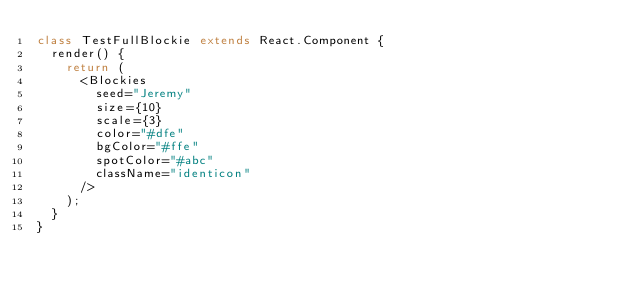<code> <loc_0><loc_0><loc_500><loc_500><_TypeScript_>class TestFullBlockie extends React.Component {
  render() {
    return (
      <Blockies
        seed="Jeremy"
        size={10}
        scale={3}
        color="#dfe"
        bgColor="#ffe"
        spotColor="#abc"
        className="identicon"
      />
    );
  }
}
</code> 